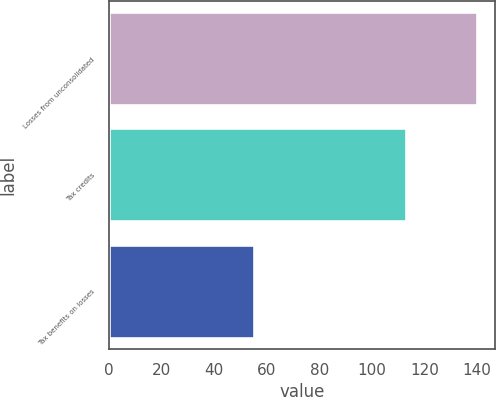<chart> <loc_0><loc_0><loc_500><loc_500><bar_chart><fcel>Losses from unconsolidated<fcel>Tax credits<fcel>Tax benefits on losses<nl><fcel>140<fcel>113<fcel>55<nl></chart> 